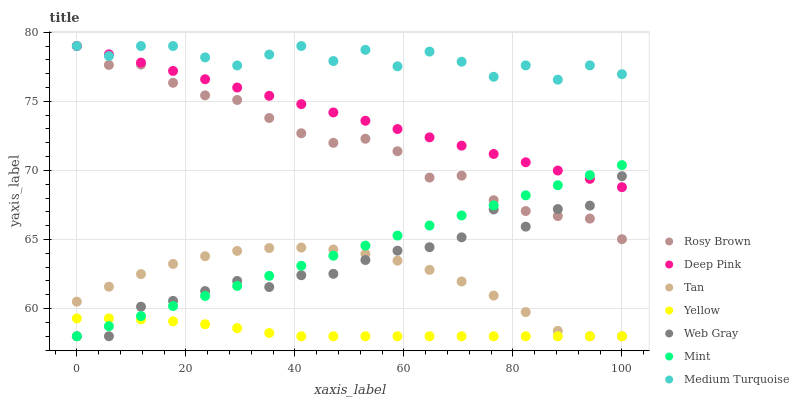Does Yellow have the minimum area under the curve?
Answer yes or no. Yes. Does Medium Turquoise have the maximum area under the curve?
Answer yes or no. Yes. Does Rosy Brown have the minimum area under the curve?
Answer yes or no. No. Does Rosy Brown have the maximum area under the curve?
Answer yes or no. No. Is Mint the smoothest?
Answer yes or no. Yes. Is Medium Turquoise the roughest?
Answer yes or no. Yes. Is Rosy Brown the smoothest?
Answer yes or no. No. Is Rosy Brown the roughest?
Answer yes or no. No. Does Web Gray have the lowest value?
Answer yes or no. Yes. Does Rosy Brown have the lowest value?
Answer yes or no. No. Does Medium Turquoise have the highest value?
Answer yes or no. Yes. Does Yellow have the highest value?
Answer yes or no. No. Is Yellow less than Deep Pink?
Answer yes or no. Yes. Is Deep Pink greater than Tan?
Answer yes or no. Yes. Does Deep Pink intersect Mint?
Answer yes or no. Yes. Is Deep Pink less than Mint?
Answer yes or no. No. Is Deep Pink greater than Mint?
Answer yes or no. No. Does Yellow intersect Deep Pink?
Answer yes or no. No. 